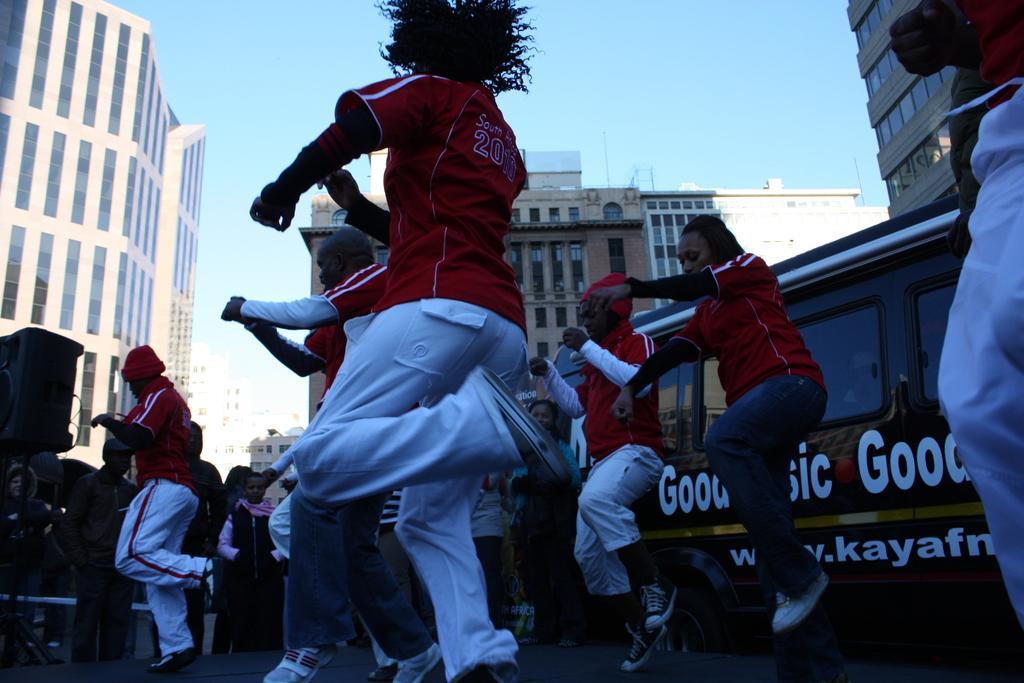Describe this image in one or two sentences. In this image in the foreground there are group of people who are dancing, and in the background there are speakers and some people are standing and there is a vehicle. At the bottom there is a road and there are some buildings, and at top there is sky. 